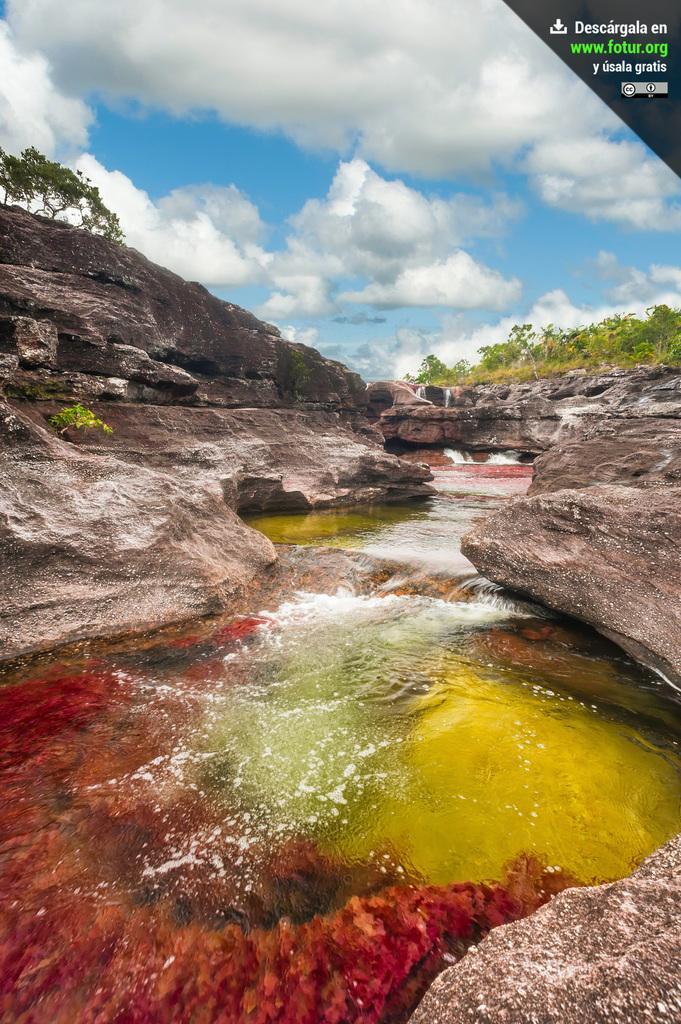Could you give a brief overview of what you see in this image? In this image I can see rocks, water, trees and cloudy sky. At the top right side of the image there is a watermark. 